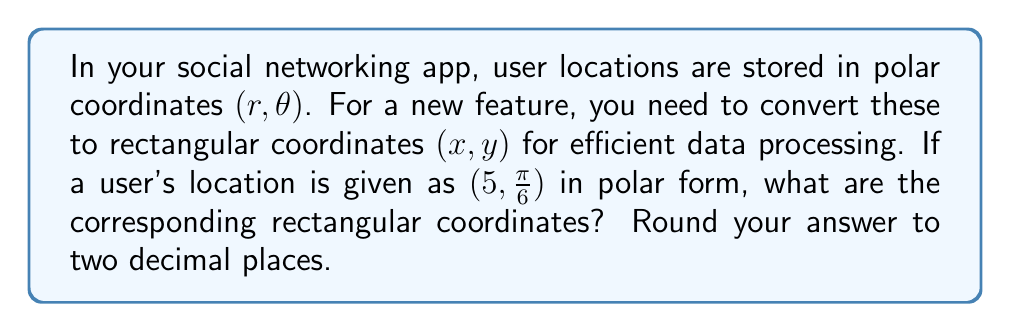What is the answer to this math problem? To convert from polar form $(r, \theta)$ to rectangular form $(x, y)$, we use the following formulas:

1. $x = r \cos(\theta)$
2. $y = r \sin(\theta)$

Given:
$r = 5$
$\theta = \frac{\pi}{6}$

Step 1: Calculate $x$
$$x = r \cos(\theta) = 5 \cos(\frac{\pi}{6})$$

$\cos(\frac{\pi}{6}) = \frac{\sqrt{3}}{2}$

$$x = 5 \cdot \frac{\sqrt{3}}{2} = \frac{5\sqrt{3}}{2} \approx 4.33$$

Step 2: Calculate $y$
$$y = r \sin(\theta) = 5 \sin(\frac{\pi}{6})$$

$\sin(\frac{\pi}{6}) = \frac{1}{2}$

$$y = 5 \cdot \frac{1}{2} = 2.5$$

Step 3: Round both values to two decimal places
$x \approx 4.33$
$y = 2.50$

Therefore, the rectangular coordinates are $(4.33, 2.50)$.
Answer: $(4.33, 2.50)$ 